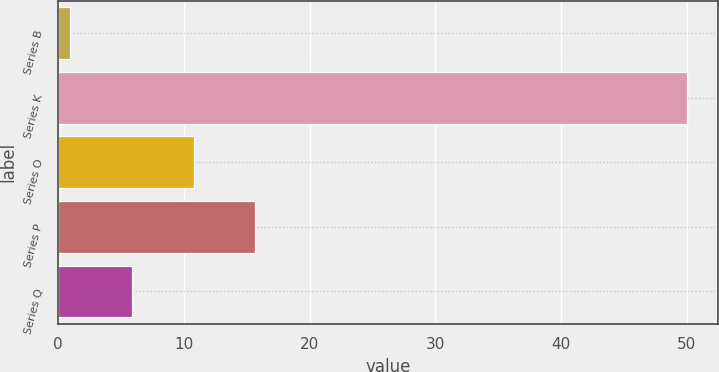<chart> <loc_0><loc_0><loc_500><loc_500><bar_chart><fcel>Series B<fcel>Series K<fcel>Series O<fcel>Series P<fcel>Series Q<nl><fcel>1<fcel>50<fcel>10.8<fcel>15.7<fcel>5.9<nl></chart> 